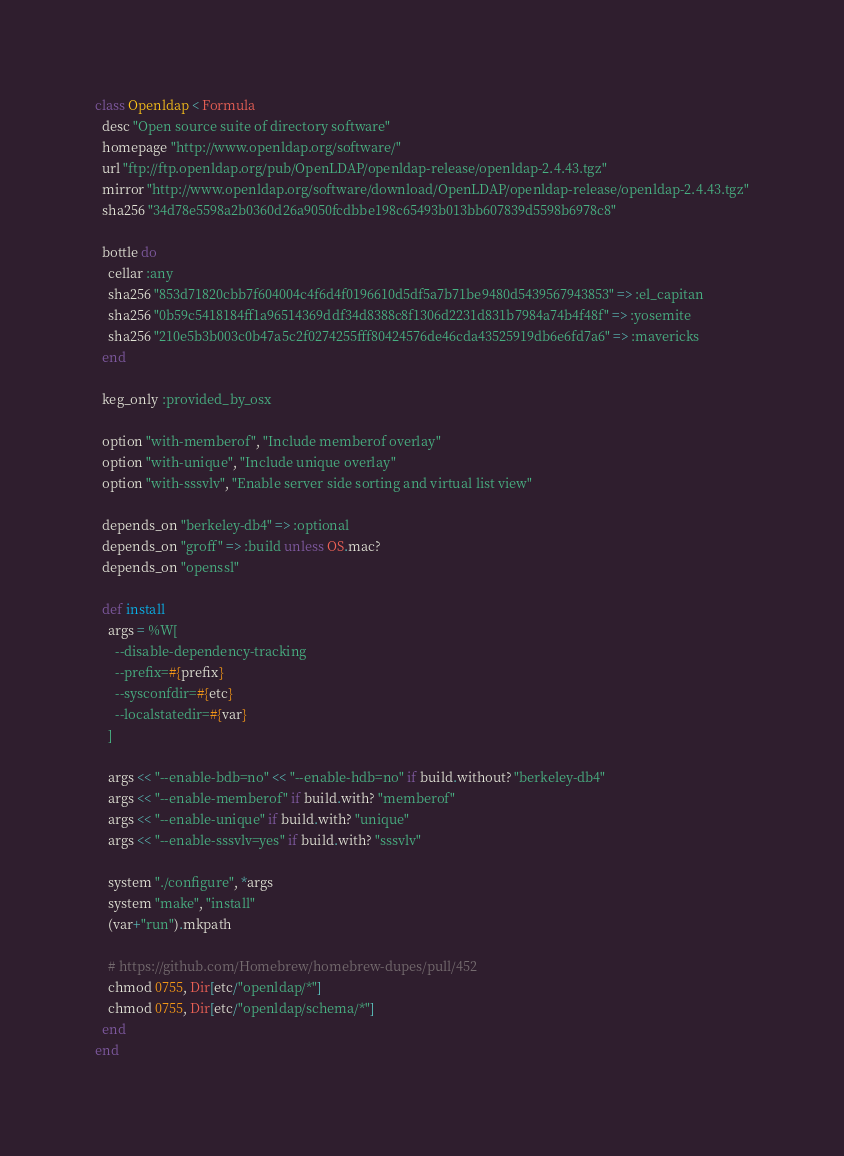<code> <loc_0><loc_0><loc_500><loc_500><_Ruby_>class Openldap < Formula
  desc "Open source suite of directory software"
  homepage "http://www.openldap.org/software/"
  url "ftp://ftp.openldap.org/pub/OpenLDAP/openldap-release/openldap-2.4.43.tgz"
  mirror "http://www.openldap.org/software/download/OpenLDAP/openldap-release/openldap-2.4.43.tgz"
  sha256 "34d78e5598a2b0360d26a9050fcdbbe198c65493b013bb607839d5598b6978c8"

  bottle do
    cellar :any
    sha256 "853d71820cbb7f604004c4f6d4f0196610d5df5a7b71be9480d5439567943853" => :el_capitan
    sha256 "0b59c5418184ff1a96514369ddf34d8388c8f1306d2231d831b7984a74b4f48f" => :yosemite
    sha256 "210e5b3b003c0b47a5c2f0274255fff80424576de46cda43525919db6e6fd7a6" => :mavericks
  end

  keg_only :provided_by_osx

  option "with-memberof", "Include memberof overlay"
  option "with-unique", "Include unique overlay"
  option "with-sssvlv", "Enable server side sorting and virtual list view"

  depends_on "berkeley-db4" => :optional
  depends_on "groff" => :build unless OS.mac?
  depends_on "openssl"

  def install
    args = %W[
      --disable-dependency-tracking
      --prefix=#{prefix}
      --sysconfdir=#{etc}
      --localstatedir=#{var}
    ]

    args << "--enable-bdb=no" << "--enable-hdb=no" if build.without? "berkeley-db4"
    args << "--enable-memberof" if build.with? "memberof"
    args << "--enable-unique" if build.with? "unique"
    args << "--enable-sssvlv=yes" if build.with? "sssvlv"

    system "./configure", *args
    system "make", "install"
    (var+"run").mkpath

    # https://github.com/Homebrew/homebrew-dupes/pull/452
    chmod 0755, Dir[etc/"openldap/*"]
    chmod 0755, Dir[etc/"openldap/schema/*"]
  end
end
</code> 